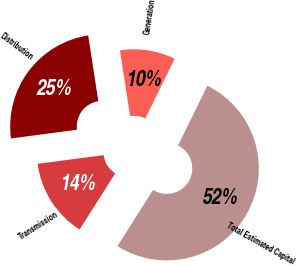Convert chart to OTSL. <chart><loc_0><loc_0><loc_500><loc_500><pie_chart><fcel>Transmission<fcel>Distribution<fcel>Generation<fcel>Total Estimated Capital<nl><fcel>13.92%<fcel>24.64%<fcel>9.72%<fcel>51.72%<nl></chart> 